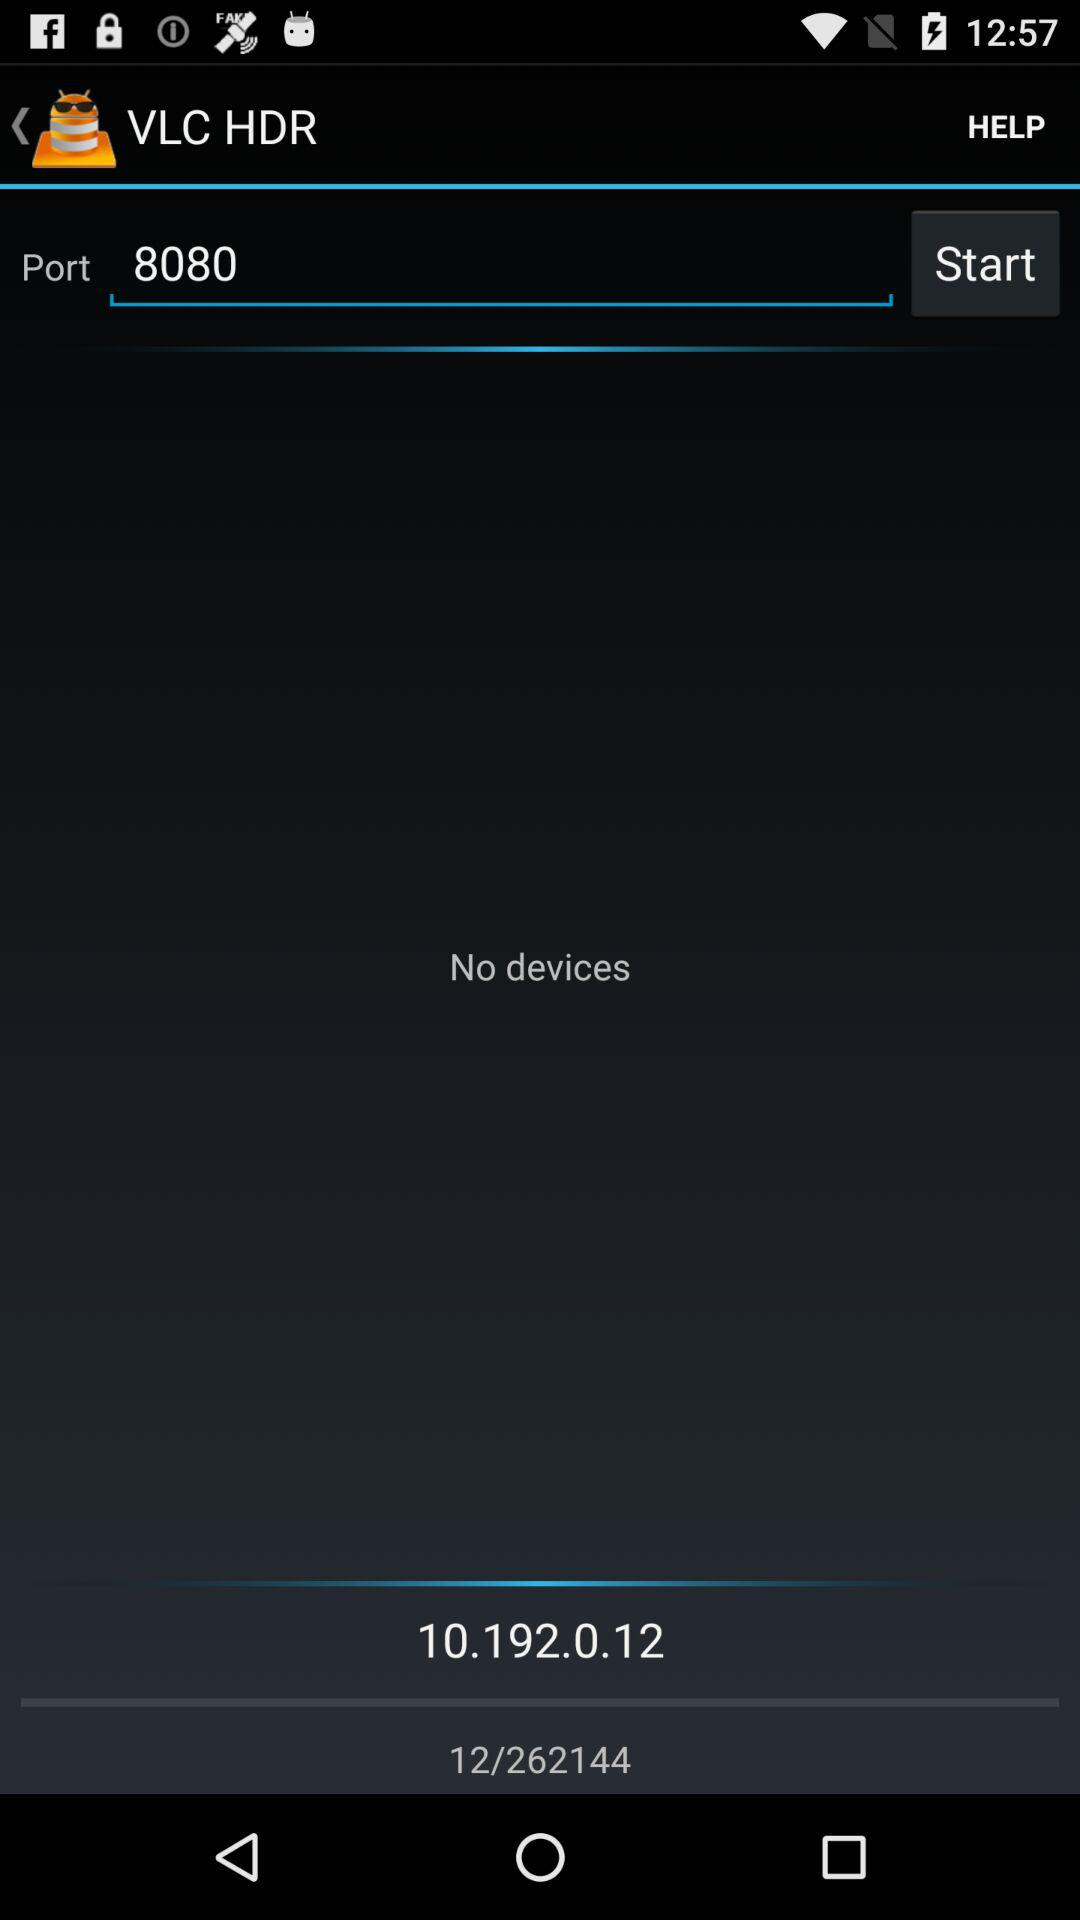What is the IP address of the device?
Answer the question using a single word or phrase. 10.192.0.12 